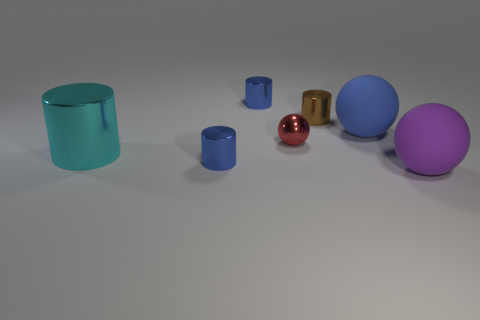What number of green things are big objects or large cubes?
Keep it short and to the point. 0. What is the material of the blue sphere that is the same size as the cyan thing?
Ensure brevity in your answer.  Rubber. There is a blue object that is behind the large cyan cylinder and in front of the tiny brown object; what shape is it?
Give a very brief answer. Sphere. There is another matte thing that is the same size as the blue rubber object; what is its color?
Offer a terse response. Purple. Do the matte sphere left of the purple rubber ball and the blue thing in front of the large blue sphere have the same size?
Offer a terse response. No. There is a sphere that is in front of the blue object that is to the left of the blue metallic object behind the cyan object; how big is it?
Your answer should be very brief. Large. The rubber object that is behind the big object in front of the big metallic cylinder is what shape?
Make the answer very short. Sphere. There is a thing that is in front of the big shiny cylinder and on the left side of the large purple object; what color is it?
Make the answer very short. Blue. Are there any large cyan blocks made of the same material as the brown cylinder?
Make the answer very short. No. What size is the blue sphere?
Give a very brief answer. Large. 